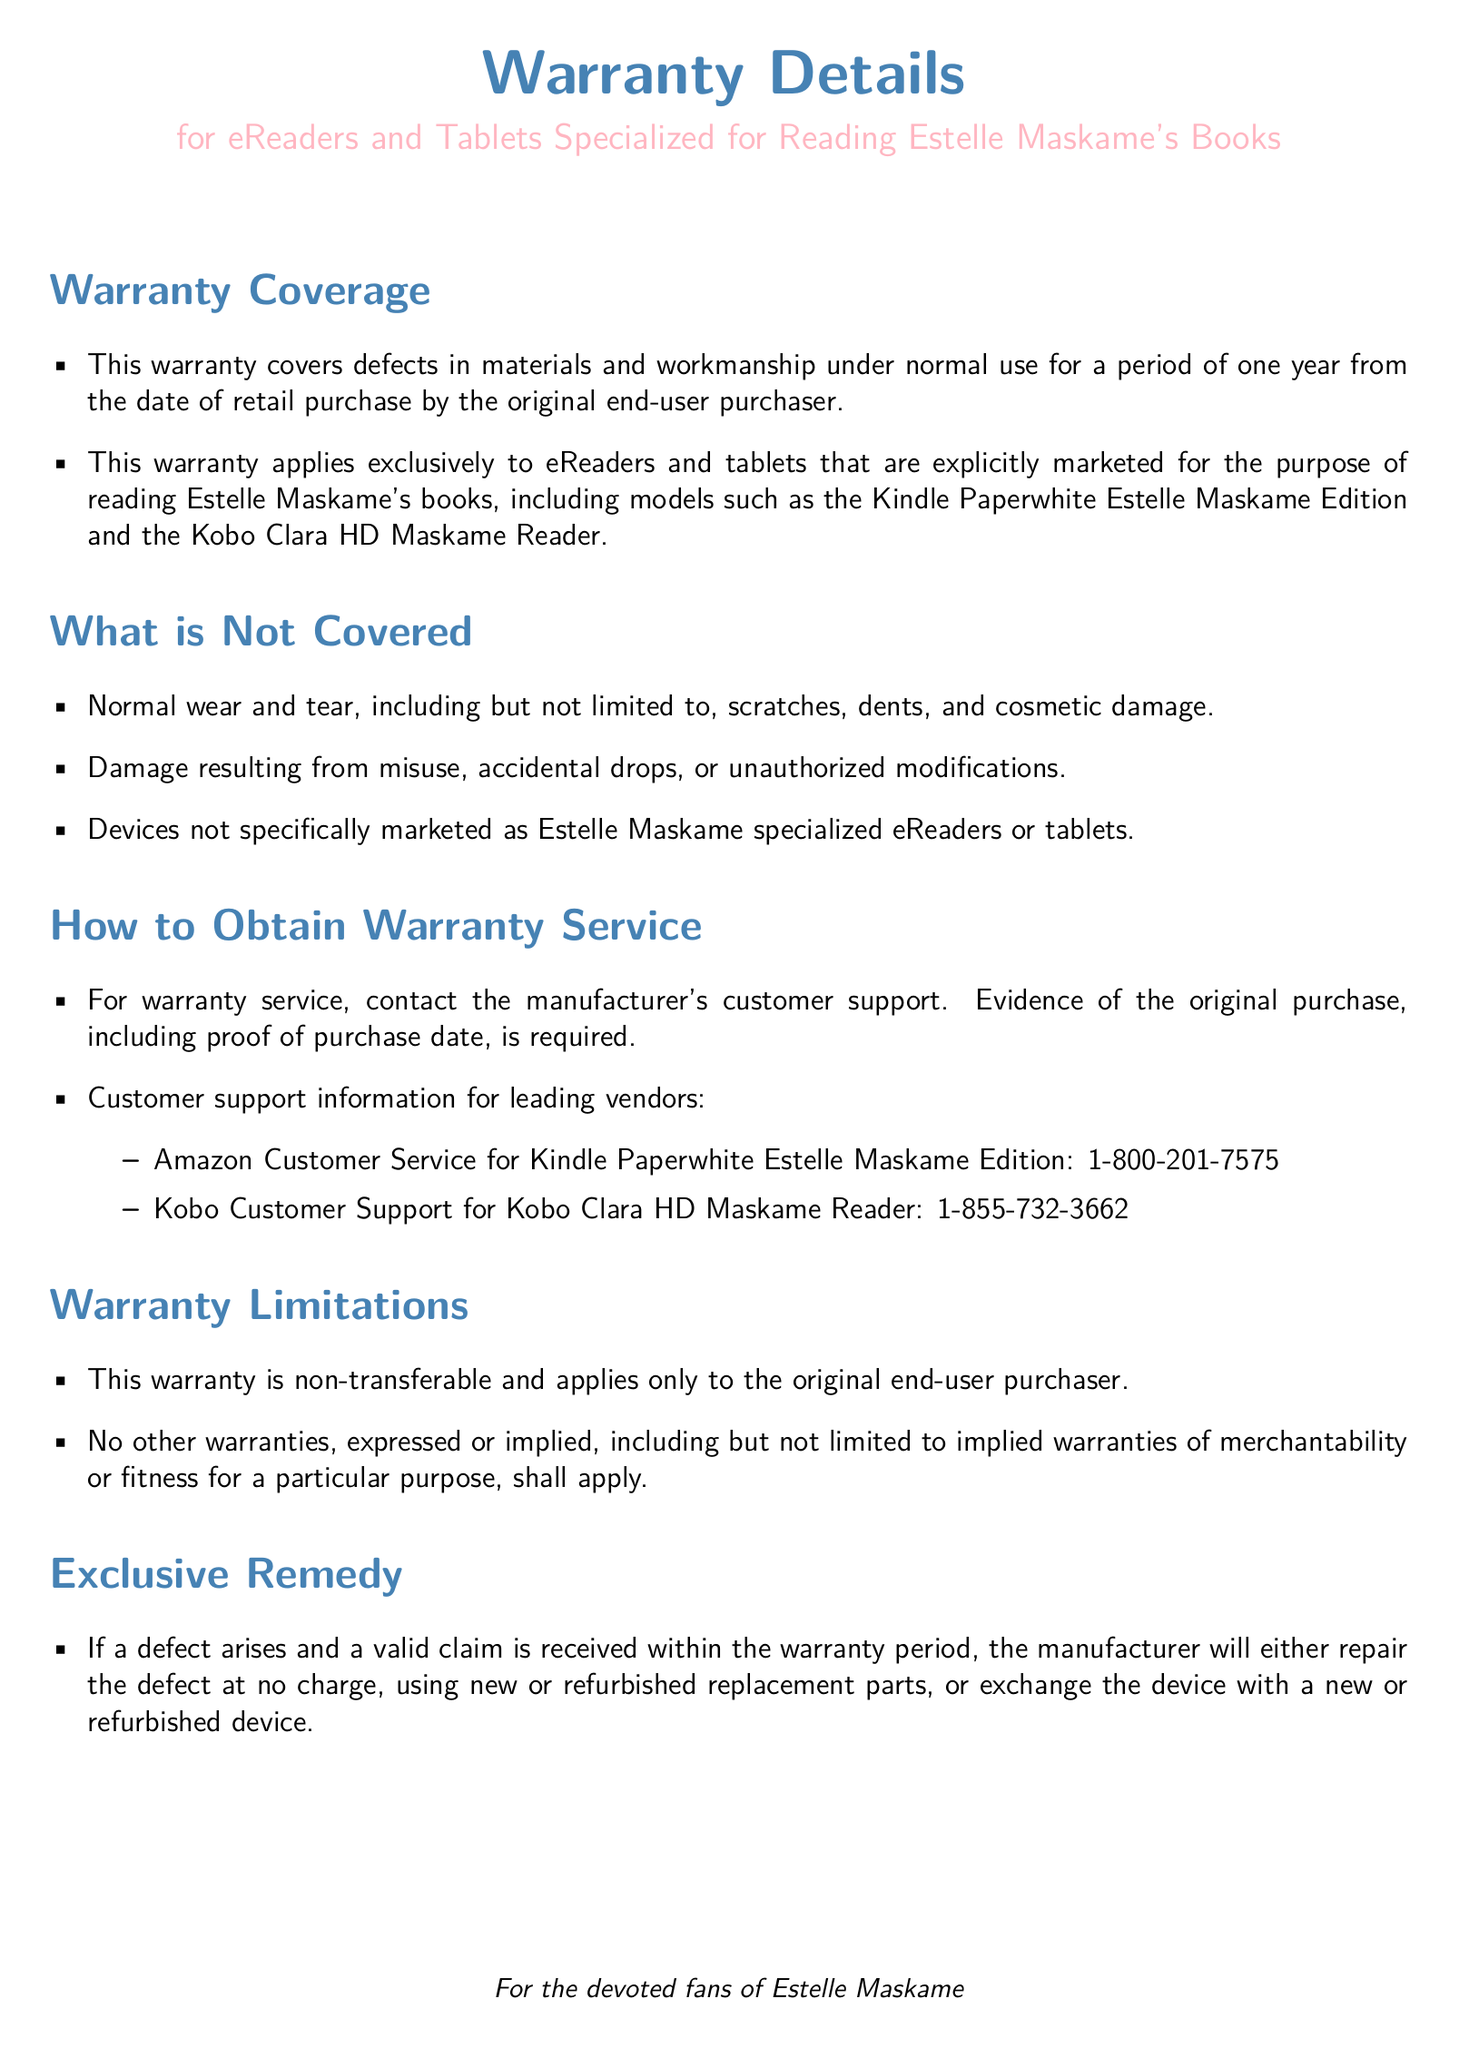What is the warranty period? The warranty period is specified as one year from the date of retail purchase by the original end-user purchaser.
Answer: one year What devices are covered under this warranty? The warranty applies only to particular eReaders and tablets, explicitly those marketed for reading Estelle Maskame's books, such as the Kindle Paperwhite Estelle Maskame Edition and the Kobo Clara HD Maskame Reader.
Answer: Kindle Paperwhite Estelle Maskame Edition and Kobo Clara HD Maskame Reader What damages are not covered by the warranty? The document lists several types of damages that are not covered, particularly those resulting from misuse, drops, and normal wear and tear.
Answer: Normal wear and tear, misuse, accidental drops How can one obtain warranty service? The document specifies contacting the manufacturer's customer support, requiring proof of purchase, to obtain warranty service.
Answer: Contact manufacturer's customer support Is the warranty transferable? The warranty limitations clearly state that the warranty is non-transferable and applies only to the original end-user purchaser.
Answer: non-transferable What is the exclusive remedy offered by the warranty? The warranty specifies that if a valid claim is received, the manufacturer will either repair the device or exchange it with a new or refurbished device.
Answer: repair or exchange What is required as evidence of the original purchase? The document mentions that evidence of the original purchase, including proof of purchase date, is required for warranty service.
Answer: proof of purchase date What type of warranty is offered? The type of warranty stated in the document covers defects in materials and workmanship under normal use.
Answer: defects in materials and workmanship 